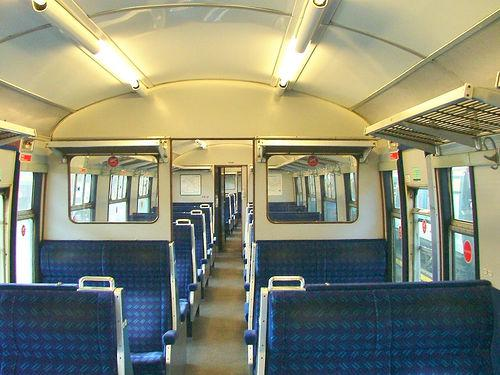Question: what color is the ground?
Choices:
A. Black.
B. White.
C. Brown.
D. Gray.
Answer with the letter. Answer: D Question: where is the photo taken?
Choices:
A. On a platform.
B. On a subway.
C. On a bus.
D. On a truck.
Answer with the letter. Answer: B Question: what color are the seats?
Choices:
A. Pink.
B. Red.
C. White.
D. Blue.
Answer with the letter. Answer: D Question: what are the metal pieces on top of the seats?
Choices:
A. Headrest extensions.
B. Buttons.
C. Tacks.
D. Handles.
Answer with the letter. Answer: D 